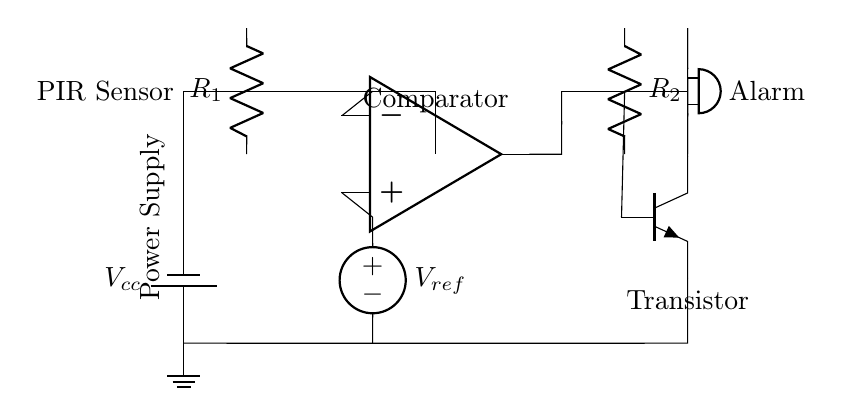What type of sensor is used in this circuit? The circuit diagram indicates a PIR (Passive Infrared) sensor, which detects motion by measuring variations in infrared radiation.
Answer: PIR Sensor What component amplifies the signal in this circuit? The op-amp, denoted in the diagram, serves as a comparator that amplifies the voltage difference between its inverting and non-inverting inputs.
Answer: Op-Amp What is the purpose of the transistor in this circuit? The transistor acts as a switch, controlling the alarm by allowing current to flow when it receives a signal from the op-amp.
Answer: Switch What is the reference voltage supplied to the op-amp? The circuit shows a voltage source labeled as V ref connected to the positive input of the op-amp, which serves as the reference voltage for comparison.
Answer: V ref How many resistors are present in the circuit? A close examination reveals two resistors, R1 and R2, connected in specific locations to manage current and affect the transistor operation.
Answer: Two What component produces the alarm sound? The circuit includes a buzzer, which is responsible for producing the sound when motion is detected, signaling an alarm condition.
Answer: Buzzer What is the power supply voltage labeled in the circuit? The diagram indicates a power supply labeled as V cc, which is the source of voltage for the entire circuit.
Answer: V cc 